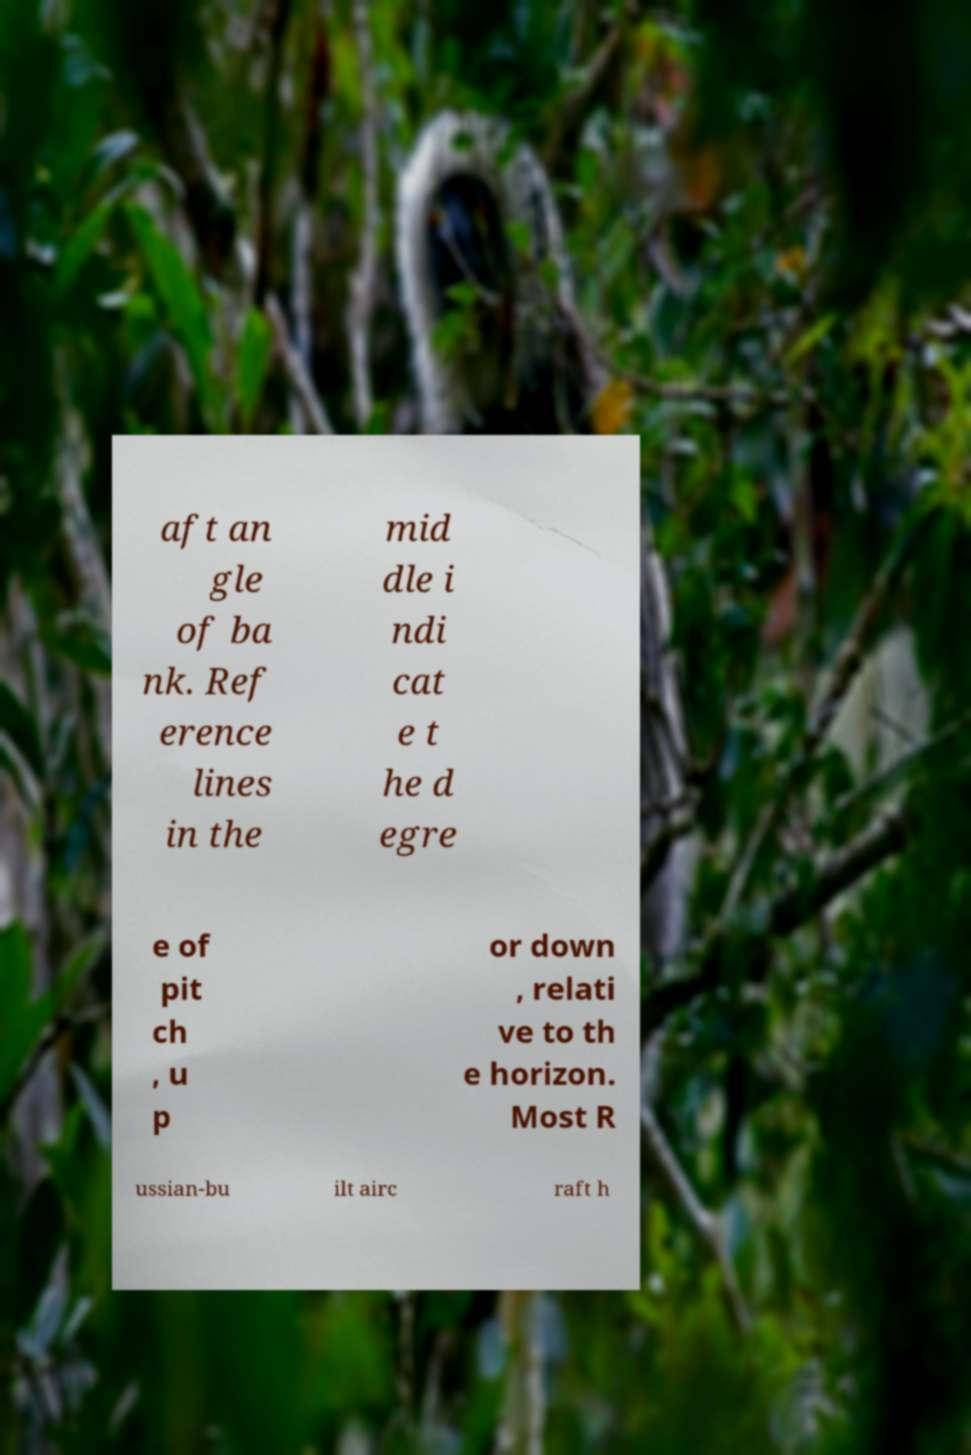Could you extract and type out the text from this image? aft an gle of ba nk. Ref erence lines in the mid dle i ndi cat e t he d egre e of pit ch , u p or down , relati ve to th e horizon. Most R ussian-bu ilt airc raft h 